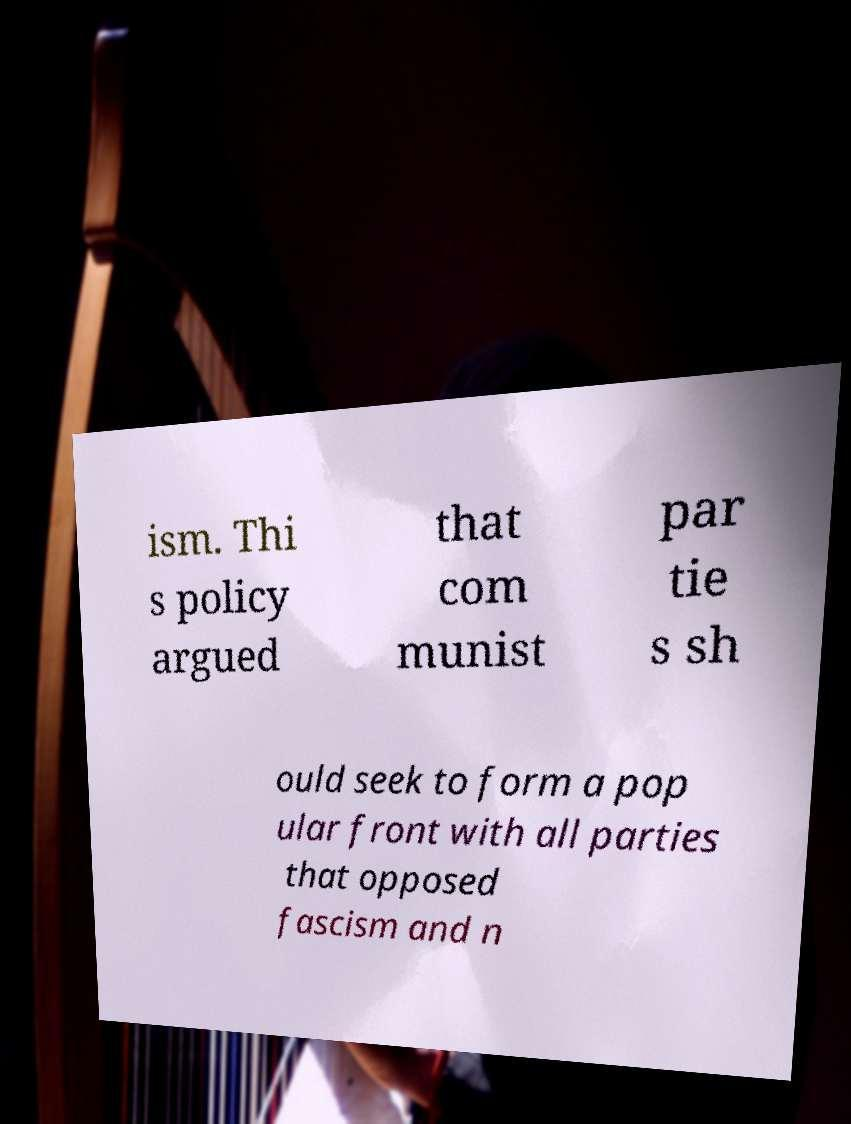What messages or text are displayed in this image? I need them in a readable, typed format. ism. Thi s policy argued that com munist par tie s sh ould seek to form a pop ular front with all parties that opposed fascism and n 